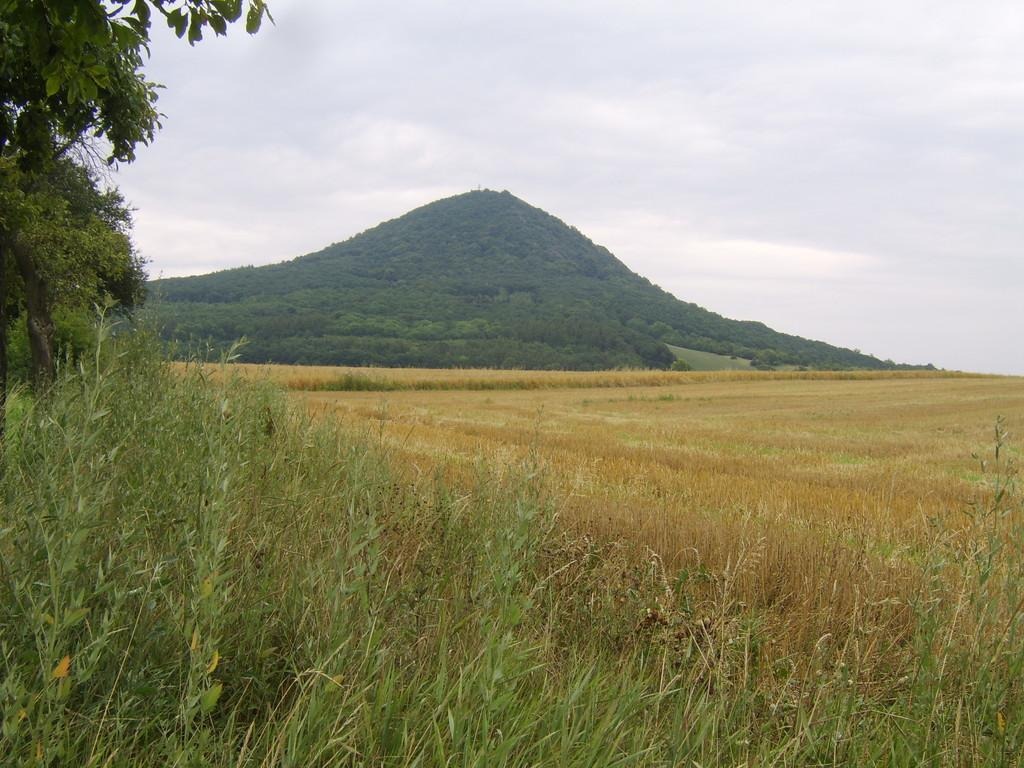What type of vegetation covers the land in the image? The land in the image is covered with grass. Are there any other natural elements present in the image? Yes, trees are present in the image. What type of geographical feature can be seen in the image? Grass mountains are visible in the image. How would you describe the sky in the image? The sky is cloudy in the image. What type of drug is being sold at the base of the grass mountains in the image? There is no indication of any drug or base in the image; it features a landscape with grass, trees, grass mountains, and a cloudy sky. 